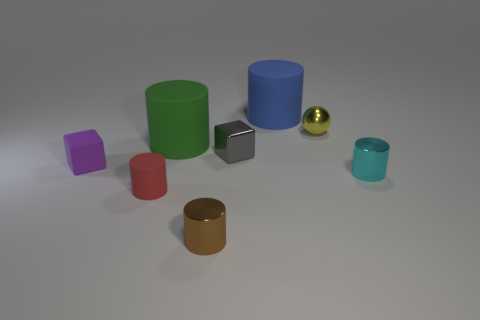Subtract all small metal cylinders. How many cylinders are left? 3 Add 1 shiny blocks. How many objects exist? 9 Subtract all red cylinders. How many cylinders are left? 4 Subtract all balls. How many objects are left? 7 Subtract all red cylinders. Subtract all cyan spheres. How many cylinders are left? 4 Add 3 metal things. How many metal things are left? 7 Add 8 metal spheres. How many metal spheres exist? 9 Subtract 1 brown cylinders. How many objects are left? 7 Subtract all small purple matte objects. Subtract all tiny yellow metallic blocks. How many objects are left? 7 